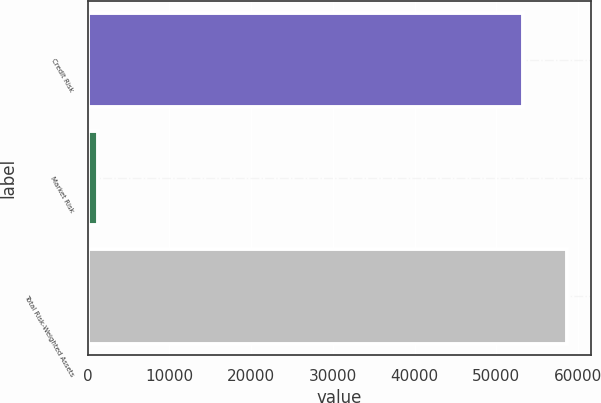Convert chart. <chart><loc_0><loc_0><loc_500><loc_500><bar_chart><fcel>Credit Risk<fcel>Market Risk<fcel>Total Risk-Weighted Assets<nl><fcel>53301<fcel>1253<fcel>58631.1<nl></chart> 